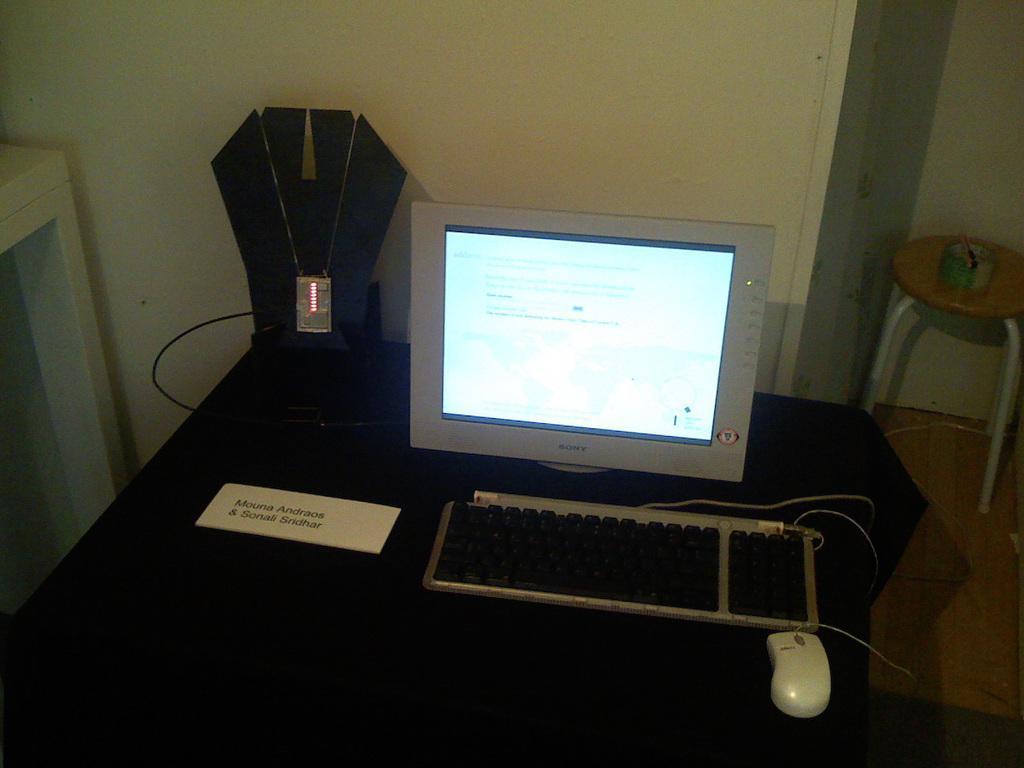How would you summarize this image in a sentence or two? In this picture we can see table on table we have key board, mouse, monitor, name card and aside to that table on table tape and in background we can see wall. 